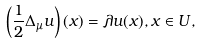<formula> <loc_0><loc_0><loc_500><loc_500>\left ( \frac { 1 } { 2 } \Delta _ { \mu } u \right ) ( x ) = \lambda u ( x ) , x \in U \/ ,</formula> 